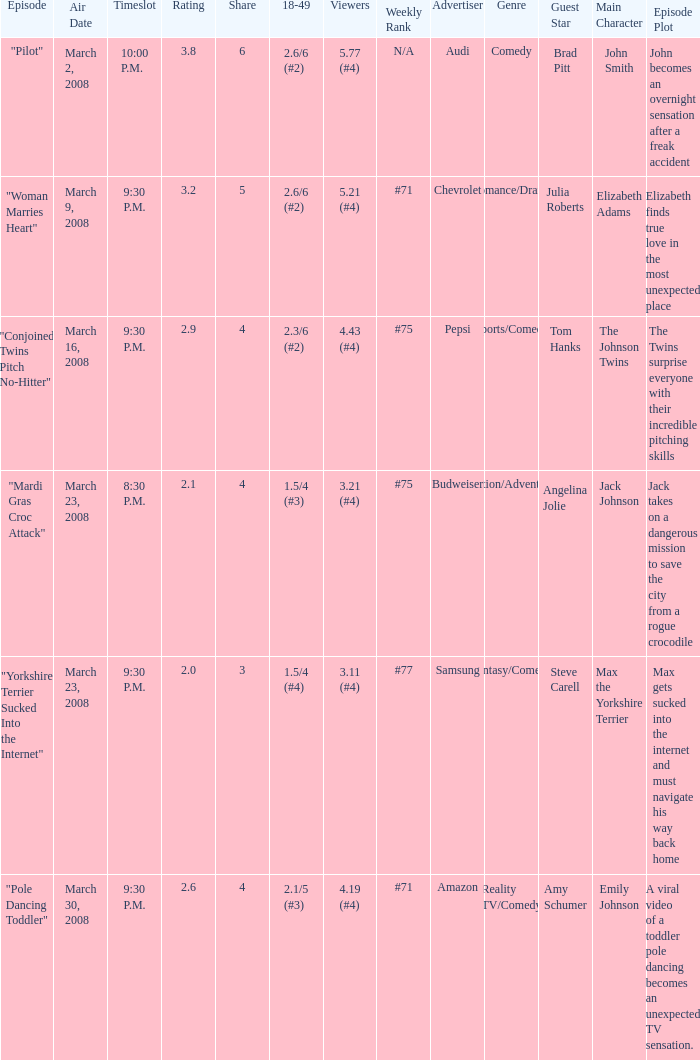What is the total ratings on share less than 4? 1.0. 